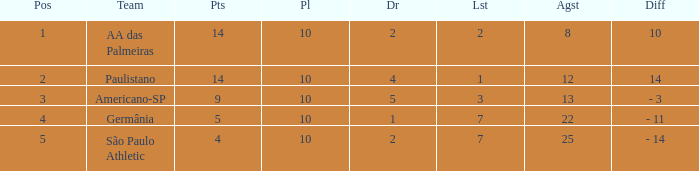What is the sum of Against when the lost is more than 7? None. 